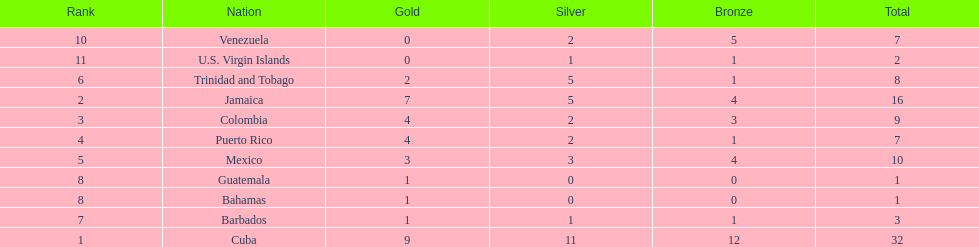What is the difference in medals between cuba and mexico? 22. 